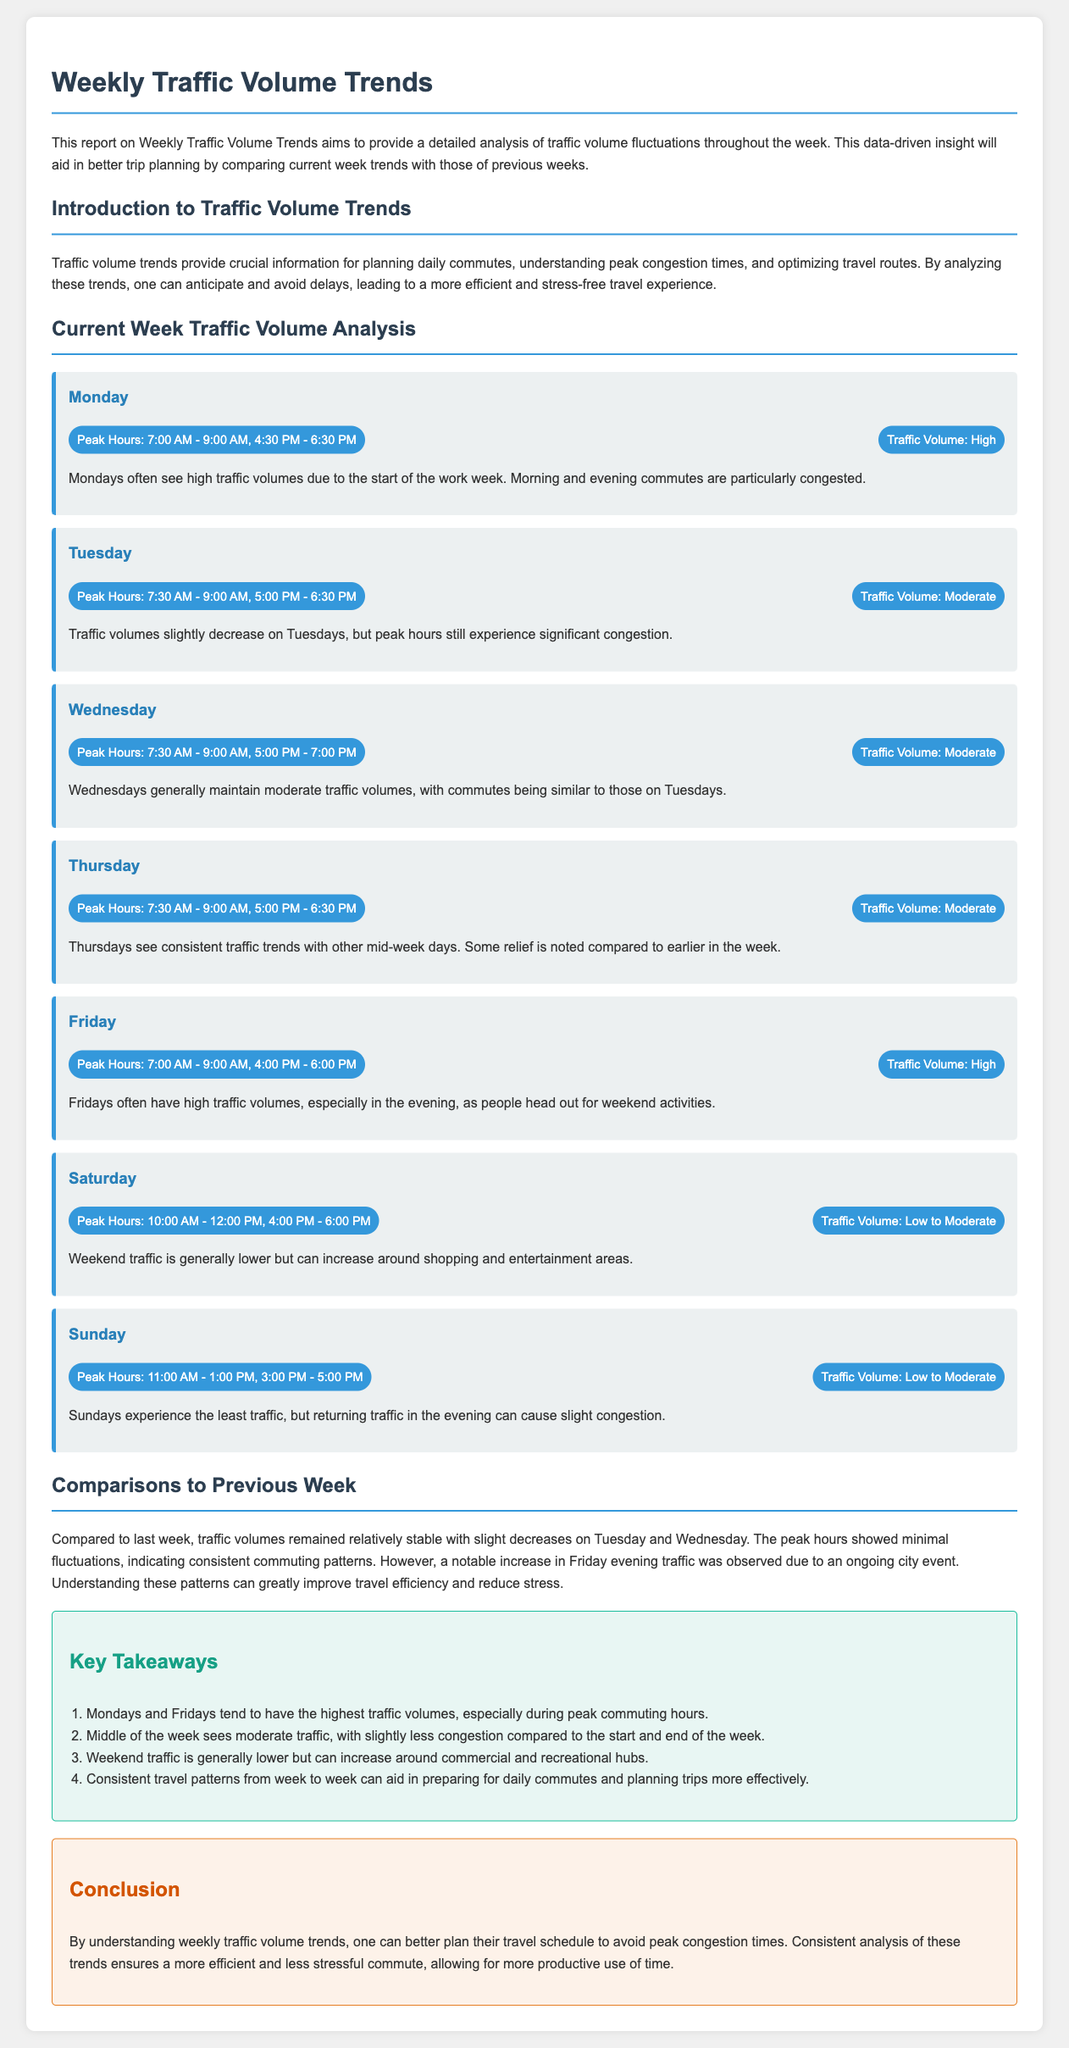What is the peak hour for Monday? The peak hours for Monday are specified in the traffic analysis, which are 7:00 AM - 9:00 AM and 4:30 PM - 6:30 PM.
Answer: 7:00 AM - 9:00 AM, 4:30 PM - 6:30 PM What traffic volume is reported for Friday? The traffic volume for Friday is described in the report, indicating that it is high.
Answer: High Which day has the lowest traffic volume? The report outlines traffic volumes, with Sunday experiencing the least traffic.
Answer: Sunday How are traffic trends on Tuesday compared to Monday? The document states that traffic volumes on Tuesday slightly decrease compared to Monday, indicating a reasoning based on comparison.
Answer: Slightly decrease What is mentioned about weekend traffic? The report notes that weekend traffic is generally lower but can increase around shopping and entertainment areas.
Answer: Lower How did the traffic volumes on Tuesday change compared to the previous week? The report specifies that there was a slight decrease in traffic volumes on Tuesday compared to last week, requiring comparison for reasoning.
Answer: Slight decrease What are the key takeaways about traffic trends? The key takeaways provide summarized insights into traffic patterns, including the highest traffic on Mondays and Fridays.
Answer: Highest traffic on Mondays and Fridays Which weekday experiences consistent traffic trends? The document indicates that Thursdays see consistent traffic trends similar to other mid-week days.
Answer: Thursdays What conclusion does the report offer regarding weekly traffic trends? The conclusion emphasizes that understanding traffic trends aids in better planning and stress reduction during commutes.
Answer: Better planning and stress reduction 